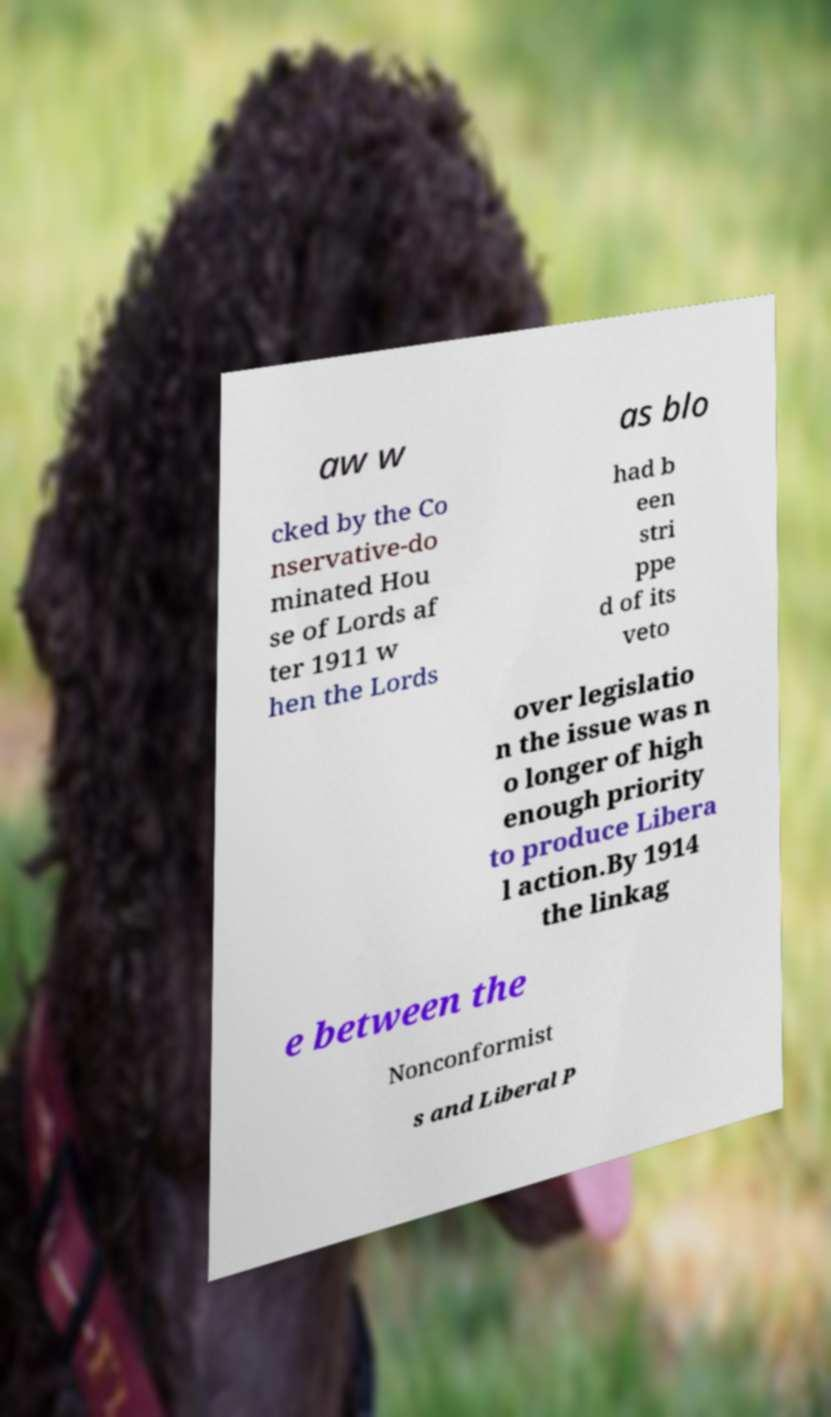What messages or text are displayed in this image? I need them in a readable, typed format. aw w as blo cked by the Co nservative-do minated Hou se of Lords af ter 1911 w hen the Lords had b een stri ppe d of its veto over legislatio n the issue was n o longer of high enough priority to produce Libera l action.By 1914 the linkag e between the Nonconformist s and Liberal P 